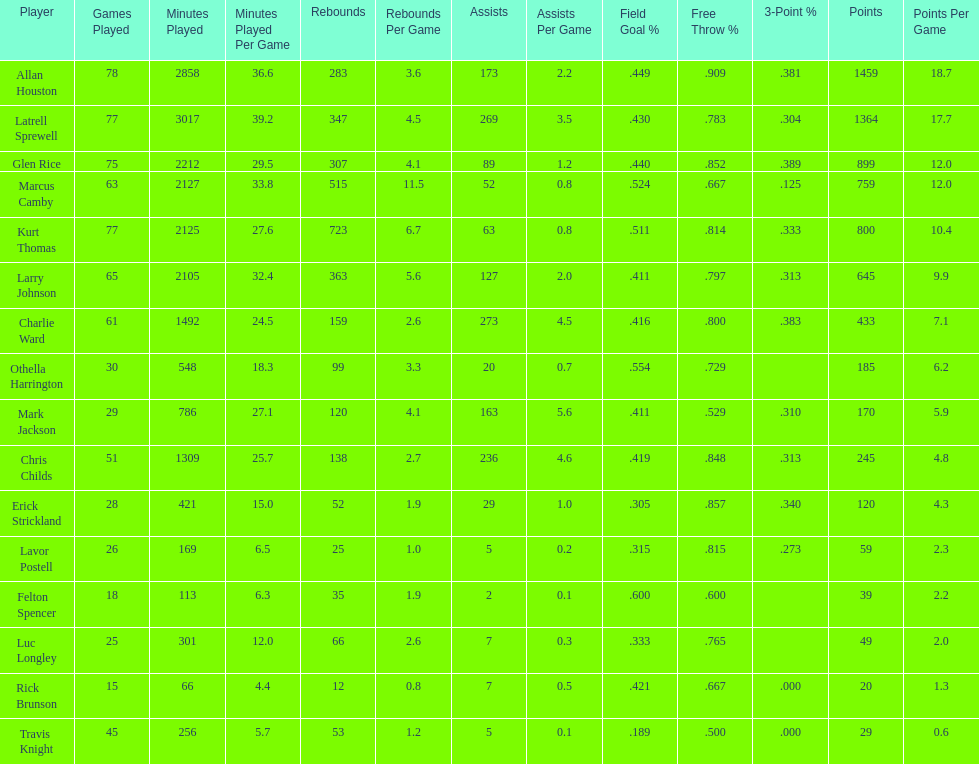Would you be able to parse every entry in this table? {'header': ['Player', 'Games Played', 'Minutes Played', 'Minutes Played Per Game', 'Rebounds', 'Rebounds Per Game', 'Assists', 'Assists Per Game', 'Field Goal\xa0%', 'Free Throw\xa0%', '3-Point\xa0%', 'Points', 'Points Per Game'], 'rows': [['Allan Houston', '78', '2858', '36.6', '283', '3.6', '173', '2.2', '.449', '.909', '.381', '1459', '18.7'], ['Latrell Sprewell', '77', '3017', '39.2', '347', '4.5', '269', '3.5', '.430', '.783', '.304', '1364', '17.7'], ['Glen Rice', '75', '2212', '29.5', '307', '4.1', '89', '1.2', '.440', '.852', '.389', '899', '12.0'], ['Marcus Camby', '63', '2127', '33.8', '515', '11.5', '52', '0.8', '.524', '.667', '.125', '759', '12.0'], ['Kurt Thomas', '77', '2125', '27.6', '723', '6.7', '63', '0.8', '.511', '.814', '.333', '800', '10.4'], ['Larry Johnson', '65', '2105', '32.4', '363', '5.6', '127', '2.0', '.411', '.797', '.313', '645', '9.9'], ['Charlie Ward', '61', '1492', '24.5', '159', '2.6', '273', '4.5', '.416', '.800', '.383', '433', '7.1'], ['Othella Harrington', '30', '548', '18.3', '99', '3.3', '20', '0.7', '.554', '.729', '', '185', '6.2'], ['Mark Jackson', '29', '786', '27.1', '120', '4.1', '163', '5.6', '.411', '.529', '.310', '170', '5.9'], ['Chris Childs', '51', '1309', '25.7', '138', '2.7', '236', '4.6', '.419', '.848', '.313', '245', '4.8'], ['Erick Strickland', '28', '421', '15.0', '52', '1.9', '29', '1.0', '.305', '.857', '.340', '120', '4.3'], ['Lavor Postell', '26', '169', '6.5', '25', '1.0', '5', '0.2', '.315', '.815', '.273', '59', '2.3'], ['Felton Spencer', '18', '113', '6.3', '35', '1.9', '2', '0.1', '.600', '.600', '', '39', '2.2'], ['Luc Longley', '25', '301', '12.0', '66', '2.6', '7', '0.3', '.333', '.765', '', '49', '2.0'], ['Rick Brunson', '15', '66', '4.4', '12', '0.8', '7', '0.5', '.421', '.667', '.000', '20', '1.3'], ['Travis Knight', '45', '256', '5.7', '53', '1.2', '5', '0.1', '.189', '.500', '.000', '29', '0.6']]} How many players possessed a field goal percentage beyond .500? 4. 